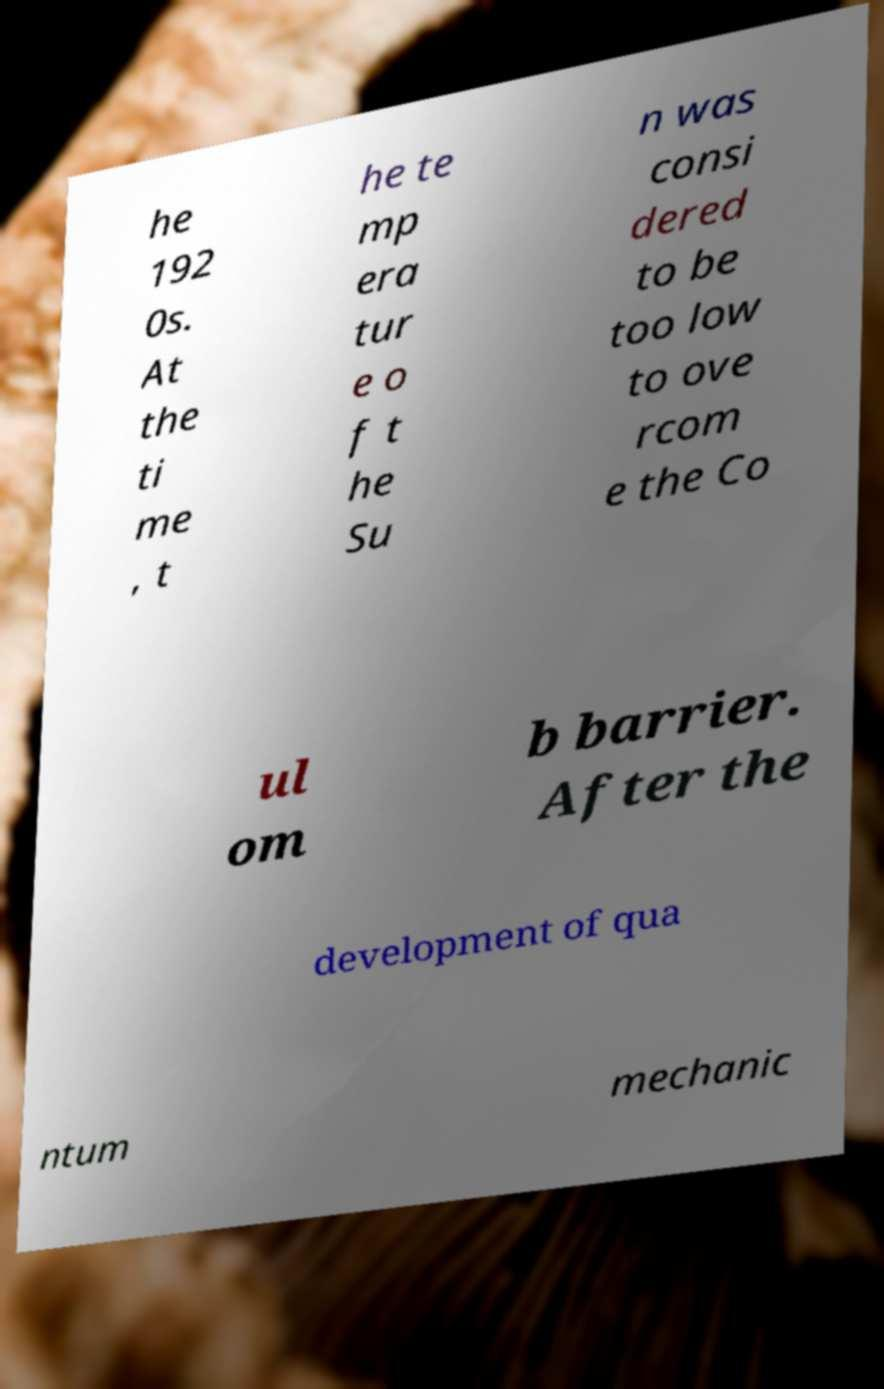Could you assist in decoding the text presented in this image and type it out clearly? he 192 0s. At the ti me , t he te mp era tur e o f t he Su n was consi dered to be too low to ove rcom e the Co ul om b barrier. After the development of qua ntum mechanic 